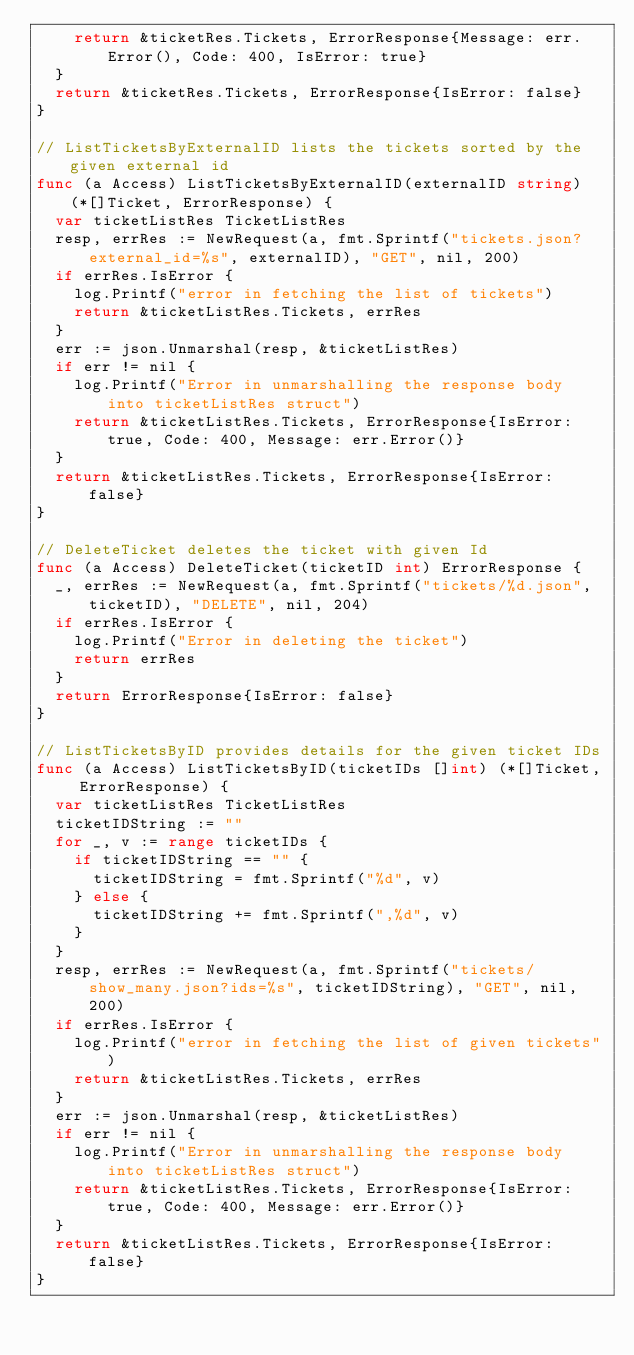Convert code to text. <code><loc_0><loc_0><loc_500><loc_500><_Go_>		return &ticketRes.Tickets, ErrorResponse{Message: err.Error(), Code: 400, IsError: true}
	}
	return &ticketRes.Tickets, ErrorResponse{IsError: false}
}

// ListTicketsByExternalID lists the tickets sorted by the given external id
func (a Access) ListTicketsByExternalID(externalID string) (*[]Ticket, ErrorResponse) {
	var ticketListRes TicketListRes
	resp, errRes := NewRequest(a, fmt.Sprintf("tickets.json?external_id=%s", externalID), "GET", nil, 200)
	if errRes.IsError {
		log.Printf("error in fetching the list of tickets")
		return &ticketListRes.Tickets, errRes
	}
	err := json.Unmarshal(resp, &ticketListRes)
	if err != nil {
		log.Printf("Error in unmarshalling the response body into ticketListRes struct")
		return &ticketListRes.Tickets, ErrorResponse{IsError: true, Code: 400, Message: err.Error()}
	}
	return &ticketListRes.Tickets, ErrorResponse{IsError: false}
}

// DeleteTicket deletes the ticket with given Id
func (a Access) DeleteTicket(ticketID int) ErrorResponse {
	_, errRes := NewRequest(a, fmt.Sprintf("tickets/%d.json", ticketID), "DELETE", nil, 204)
	if errRes.IsError {
		log.Printf("Error in deleting the ticket")
		return errRes
	}
	return ErrorResponse{IsError: false}
}

// ListTicketsByID provides details for the given ticket IDs
func (a Access) ListTicketsByID(ticketIDs []int) (*[]Ticket, ErrorResponse) {
	var ticketListRes TicketListRes
	ticketIDString := ""
	for _, v := range ticketIDs {
		if ticketIDString == "" {
			ticketIDString = fmt.Sprintf("%d", v)
		} else {
			ticketIDString += fmt.Sprintf(",%d", v)
		}
	}
	resp, errRes := NewRequest(a, fmt.Sprintf("tickets/show_many.json?ids=%s", ticketIDString), "GET", nil, 200)
	if errRes.IsError {
		log.Printf("error in fetching the list of given tickets")
		return &ticketListRes.Tickets, errRes
	}
	err := json.Unmarshal(resp, &ticketListRes)
	if err != nil {
		log.Printf("Error in unmarshalling the response body into ticketListRes struct")
		return &ticketListRes.Tickets, ErrorResponse{IsError: true, Code: 400, Message: err.Error()}
	}
	return &ticketListRes.Tickets, ErrorResponse{IsError: false}
}
</code> 